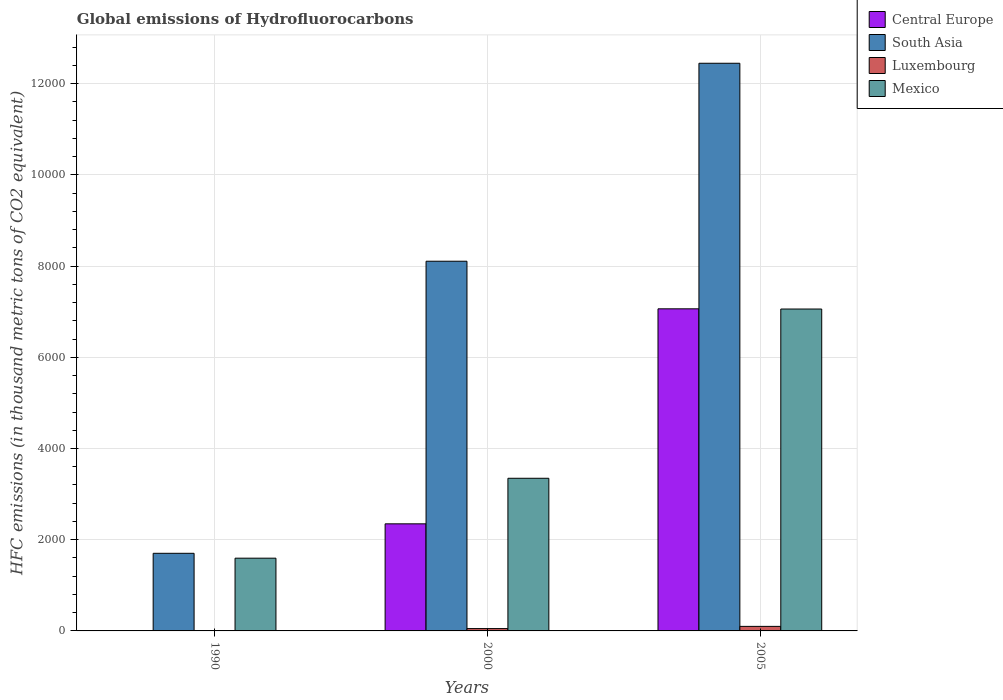Are the number of bars on each tick of the X-axis equal?
Offer a terse response. Yes. How many bars are there on the 1st tick from the right?
Your response must be concise. 4. What is the global emissions of Hydrofluorocarbons in Mexico in 1990?
Make the answer very short. 1595.3. Across all years, what is the maximum global emissions of Hydrofluorocarbons in Central Europe?
Give a very brief answer. 7063.3. In which year was the global emissions of Hydrofluorocarbons in Mexico maximum?
Your answer should be very brief. 2005. What is the total global emissions of Hydrofluorocarbons in South Asia in the graph?
Offer a terse response. 2.23e+04. What is the difference between the global emissions of Hydrofluorocarbons in South Asia in 2000 and that in 2005?
Ensure brevity in your answer.  -4341.26. What is the difference between the global emissions of Hydrofluorocarbons in Mexico in 2000 and the global emissions of Hydrofluorocarbons in South Asia in 1990?
Give a very brief answer. 1645.2. What is the average global emissions of Hydrofluorocarbons in South Asia per year?
Make the answer very short. 7419.25. In the year 1990, what is the difference between the global emissions of Hydrofluorocarbons in Luxembourg and global emissions of Hydrofluorocarbons in South Asia?
Give a very brief answer. -1702. What is the ratio of the global emissions of Hydrofluorocarbons in Central Europe in 1990 to that in 2005?
Your response must be concise. 7.078844166324523e-5. What is the difference between the highest and the second highest global emissions of Hydrofluorocarbons in Mexico?
Provide a succinct answer. 3711.6. What is the difference between the highest and the lowest global emissions of Hydrofluorocarbons in Luxembourg?
Your answer should be compact. 99.4. In how many years, is the global emissions of Hydrofluorocarbons in Luxembourg greater than the average global emissions of Hydrofluorocarbons in Luxembourg taken over all years?
Your response must be concise. 2. Is the sum of the global emissions of Hydrofluorocarbons in Luxembourg in 1990 and 2005 greater than the maximum global emissions of Hydrofluorocarbons in Mexico across all years?
Your answer should be very brief. No. Is it the case that in every year, the sum of the global emissions of Hydrofluorocarbons in Mexico and global emissions of Hydrofluorocarbons in Luxembourg is greater than the sum of global emissions of Hydrofluorocarbons in South Asia and global emissions of Hydrofluorocarbons in Central Europe?
Provide a short and direct response. No. What does the 4th bar from the left in 2005 represents?
Offer a terse response. Mexico. What does the 2nd bar from the right in 1990 represents?
Provide a short and direct response. Luxembourg. How many bars are there?
Ensure brevity in your answer.  12. How many years are there in the graph?
Offer a terse response. 3. What is the difference between two consecutive major ticks on the Y-axis?
Give a very brief answer. 2000. Are the values on the major ticks of Y-axis written in scientific E-notation?
Ensure brevity in your answer.  No. Does the graph contain any zero values?
Give a very brief answer. No. Does the graph contain grids?
Keep it short and to the point. Yes. How are the legend labels stacked?
Offer a very short reply. Vertical. What is the title of the graph?
Your answer should be compact. Global emissions of Hydrofluorocarbons. What is the label or title of the Y-axis?
Your answer should be very brief. HFC emissions (in thousand metric tons of CO2 equivalent). What is the HFC emissions (in thousand metric tons of CO2 equivalent) in Central Europe in 1990?
Your answer should be compact. 0.5. What is the HFC emissions (in thousand metric tons of CO2 equivalent) in South Asia in 1990?
Offer a very short reply. 1702.1. What is the HFC emissions (in thousand metric tons of CO2 equivalent) of Luxembourg in 1990?
Offer a very short reply. 0.1. What is the HFC emissions (in thousand metric tons of CO2 equivalent) in Mexico in 1990?
Offer a very short reply. 1595.3. What is the HFC emissions (in thousand metric tons of CO2 equivalent) of Central Europe in 2000?
Offer a terse response. 2348.2. What is the HFC emissions (in thousand metric tons of CO2 equivalent) of South Asia in 2000?
Give a very brief answer. 8107.2. What is the HFC emissions (in thousand metric tons of CO2 equivalent) in Luxembourg in 2000?
Your response must be concise. 51.1. What is the HFC emissions (in thousand metric tons of CO2 equivalent) of Mexico in 2000?
Provide a short and direct response. 3347.3. What is the HFC emissions (in thousand metric tons of CO2 equivalent) of Central Europe in 2005?
Offer a very short reply. 7063.3. What is the HFC emissions (in thousand metric tons of CO2 equivalent) of South Asia in 2005?
Your answer should be very brief. 1.24e+04. What is the HFC emissions (in thousand metric tons of CO2 equivalent) of Luxembourg in 2005?
Your answer should be very brief. 99.5. What is the HFC emissions (in thousand metric tons of CO2 equivalent) of Mexico in 2005?
Provide a succinct answer. 7058.9. Across all years, what is the maximum HFC emissions (in thousand metric tons of CO2 equivalent) in Central Europe?
Offer a very short reply. 7063.3. Across all years, what is the maximum HFC emissions (in thousand metric tons of CO2 equivalent) of South Asia?
Offer a terse response. 1.24e+04. Across all years, what is the maximum HFC emissions (in thousand metric tons of CO2 equivalent) of Luxembourg?
Give a very brief answer. 99.5. Across all years, what is the maximum HFC emissions (in thousand metric tons of CO2 equivalent) of Mexico?
Your answer should be very brief. 7058.9. Across all years, what is the minimum HFC emissions (in thousand metric tons of CO2 equivalent) in South Asia?
Provide a short and direct response. 1702.1. Across all years, what is the minimum HFC emissions (in thousand metric tons of CO2 equivalent) of Luxembourg?
Your response must be concise. 0.1. Across all years, what is the minimum HFC emissions (in thousand metric tons of CO2 equivalent) in Mexico?
Your response must be concise. 1595.3. What is the total HFC emissions (in thousand metric tons of CO2 equivalent) of Central Europe in the graph?
Offer a terse response. 9412. What is the total HFC emissions (in thousand metric tons of CO2 equivalent) in South Asia in the graph?
Provide a short and direct response. 2.23e+04. What is the total HFC emissions (in thousand metric tons of CO2 equivalent) of Luxembourg in the graph?
Your answer should be compact. 150.7. What is the total HFC emissions (in thousand metric tons of CO2 equivalent) in Mexico in the graph?
Your answer should be compact. 1.20e+04. What is the difference between the HFC emissions (in thousand metric tons of CO2 equivalent) in Central Europe in 1990 and that in 2000?
Offer a terse response. -2347.7. What is the difference between the HFC emissions (in thousand metric tons of CO2 equivalent) in South Asia in 1990 and that in 2000?
Offer a very short reply. -6405.1. What is the difference between the HFC emissions (in thousand metric tons of CO2 equivalent) in Luxembourg in 1990 and that in 2000?
Provide a succinct answer. -51. What is the difference between the HFC emissions (in thousand metric tons of CO2 equivalent) of Mexico in 1990 and that in 2000?
Ensure brevity in your answer.  -1752. What is the difference between the HFC emissions (in thousand metric tons of CO2 equivalent) in Central Europe in 1990 and that in 2005?
Provide a short and direct response. -7062.8. What is the difference between the HFC emissions (in thousand metric tons of CO2 equivalent) in South Asia in 1990 and that in 2005?
Your answer should be compact. -1.07e+04. What is the difference between the HFC emissions (in thousand metric tons of CO2 equivalent) of Luxembourg in 1990 and that in 2005?
Ensure brevity in your answer.  -99.4. What is the difference between the HFC emissions (in thousand metric tons of CO2 equivalent) in Mexico in 1990 and that in 2005?
Offer a terse response. -5463.6. What is the difference between the HFC emissions (in thousand metric tons of CO2 equivalent) in Central Europe in 2000 and that in 2005?
Keep it short and to the point. -4715.1. What is the difference between the HFC emissions (in thousand metric tons of CO2 equivalent) in South Asia in 2000 and that in 2005?
Keep it short and to the point. -4341.26. What is the difference between the HFC emissions (in thousand metric tons of CO2 equivalent) of Luxembourg in 2000 and that in 2005?
Offer a terse response. -48.4. What is the difference between the HFC emissions (in thousand metric tons of CO2 equivalent) in Mexico in 2000 and that in 2005?
Your answer should be very brief. -3711.6. What is the difference between the HFC emissions (in thousand metric tons of CO2 equivalent) in Central Europe in 1990 and the HFC emissions (in thousand metric tons of CO2 equivalent) in South Asia in 2000?
Ensure brevity in your answer.  -8106.7. What is the difference between the HFC emissions (in thousand metric tons of CO2 equivalent) in Central Europe in 1990 and the HFC emissions (in thousand metric tons of CO2 equivalent) in Luxembourg in 2000?
Give a very brief answer. -50.6. What is the difference between the HFC emissions (in thousand metric tons of CO2 equivalent) in Central Europe in 1990 and the HFC emissions (in thousand metric tons of CO2 equivalent) in Mexico in 2000?
Offer a very short reply. -3346.8. What is the difference between the HFC emissions (in thousand metric tons of CO2 equivalent) of South Asia in 1990 and the HFC emissions (in thousand metric tons of CO2 equivalent) of Luxembourg in 2000?
Your answer should be compact. 1651. What is the difference between the HFC emissions (in thousand metric tons of CO2 equivalent) of South Asia in 1990 and the HFC emissions (in thousand metric tons of CO2 equivalent) of Mexico in 2000?
Your answer should be very brief. -1645.2. What is the difference between the HFC emissions (in thousand metric tons of CO2 equivalent) of Luxembourg in 1990 and the HFC emissions (in thousand metric tons of CO2 equivalent) of Mexico in 2000?
Provide a short and direct response. -3347.2. What is the difference between the HFC emissions (in thousand metric tons of CO2 equivalent) in Central Europe in 1990 and the HFC emissions (in thousand metric tons of CO2 equivalent) in South Asia in 2005?
Offer a very short reply. -1.24e+04. What is the difference between the HFC emissions (in thousand metric tons of CO2 equivalent) of Central Europe in 1990 and the HFC emissions (in thousand metric tons of CO2 equivalent) of Luxembourg in 2005?
Provide a succinct answer. -99. What is the difference between the HFC emissions (in thousand metric tons of CO2 equivalent) in Central Europe in 1990 and the HFC emissions (in thousand metric tons of CO2 equivalent) in Mexico in 2005?
Keep it short and to the point. -7058.4. What is the difference between the HFC emissions (in thousand metric tons of CO2 equivalent) of South Asia in 1990 and the HFC emissions (in thousand metric tons of CO2 equivalent) of Luxembourg in 2005?
Provide a succinct answer. 1602.6. What is the difference between the HFC emissions (in thousand metric tons of CO2 equivalent) of South Asia in 1990 and the HFC emissions (in thousand metric tons of CO2 equivalent) of Mexico in 2005?
Keep it short and to the point. -5356.8. What is the difference between the HFC emissions (in thousand metric tons of CO2 equivalent) in Luxembourg in 1990 and the HFC emissions (in thousand metric tons of CO2 equivalent) in Mexico in 2005?
Make the answer very short. -7058.8. What is the difference between the HFC emissions (in thousand metric tons of CO2 equivalent) in Central Europe in 2000 and the HFC emissions (in thousand metric tons of CO2 equivalent) in South Asia in 2005?
Offer a terse response. -1.01e+04. What is the difference between the HFC emissions (in thousand metric tons of CO2 equivalent) of Central Europe in 2000 and the HFC emissions (in thousand metric tons of CO2 equivalent) of Luxembourg in 2005?
Ensure brevity in your answer.  2248.7. What is the difference between the HFC emissions (in thousand metric tons of CO2 equivalent) in Central Europe in 2000 and the HFC emissions (in thousand metric tons of CO2 equivalent) in Mexico in 2005?
Provide a succinct answer. -4710.7. What is the difference between the HFC emissions (in thousand metric tons of CO2 equivalent) in South Asia in 2000 and the HFC emissions (in thousand metric tons of CO2 equivalent) in Luxembourg in 2005?
Provide a short and direct response. 8007.7. What is the difference between the HFC emissions (in thousand metric tons of CO2 equivalent) of South Asia in 2000 and the HFC emissions (in thousand metric tons of CO2 equivalent) of Mexico in 2005?
Make the answer very short. 1048.3. What is the difference between the HFC emissions (in thousand metric tons of CO2 equivalent) in Luxembourg in 2000 and the HFC emissions (in thousand metric tons of CO2 equivalent) in Mexico in 2005?
Offer a very short reply. -7007.8. What is the average HFC emissions (in thousand metric tons of CO2 equivalent) in Central Europe per year?
Provide a short and direct response. 3137.33. What is the average HFC emissions (in thousand metric tons of CO2 equivalent) in South Asia per year?
Your answer should be compact. 7419.25. What is the average HFC emissions (in thousand metric tons of CO2 equivalent) in Luxembourg per year?
Your answer should be very brief. 50.23. What is the average HFC emissions (in thousand metric tons of CO2 equivalent) in Mexico per year?
Keep it short and to the point. 4000.5. In the year 1990, what is the difference between the HFC emissions (in thousand metric tons of CO2 equivalent) of Central Europe and HFC emissions (in thousand metric tons of CO2 equivalent) of South Asia?
Give a very brief answer. -1701.6. In the year 1990, what is the difference between the HFC emissions (in thousand metric tons of CO2 equivalent) in Central Europe and HFC emissions (in thousand metric tons of CO2 equivalent) in Mexico?
Provide a short and direct response. -1594.8. In the year 1990, what is the difference between the HFC emissions (in thousand metric tons of CO2 equivalent) in South Asia and HFC emissions (in thousand metric tons of CO2 equivalent) in Luxembourg?
Provide a succinct answer. 1702. In the year 1990, what is the difference between the HFC emissions (in thousand metric tons of CO2 equivalent) of South Asia and HFC emissions (in thousand metric tons of CO2 equivalent) of Mexico?
Make the answer very short. 106.8. In the year 1990, what is the difference between the HFC emissions (in thousand metric tons of CO2 equivalent) of Luxembourg and HFC emissions (in thousand metric tons of CO2 equivalent) of Mexico?
Ensure brevity in your answer.  -1595.2. In the year 2000, what is the difference between the HFC emissions (in thousand metric tons of CO2 equivalent) in Central Europe and HFC emissions (in thousand metric tons of CO2 equivalent) in South Asia?
Provide a short and direct response. -5759. In the year 2000, what is the difference between the HFC emissions (in thousand metric tons of CO2 equivalent) of Central Europe and HFC emissions (in thousand metric tons of CO2 equivalent) of Luxembourg?
Make the answer very short. 2297.1. In the year 2000, what is the difference between the HFC emissions (in thousand metric tons of CO2 equivalent) in Central Europe and HFC emissions (in thousand metric tons of CO2 equivalent) in Mexico?
Give a very brief answer. -999.1. In the year 2000, what is the difference between the HFC emissions (in thousand metric tons of CO2 equivalent) of South Asia and HFC emissions (in thousand metric tons of CO2 equivalent) of Luxembourg?
Keep it short and to the point. 8056.1. In the year 2000, what is the difference between the HFC emissions (in thousand metric tons of CO2 equivalent) of South Asia and HFC emissions (in thousand metric tons of CO2 equivalent) of Mexico?
Provide a succinct answer. 4759.9. In the year 2000, what is the difference between the HFC emissions (in thousand metric tons of CO2 equivalent) of Luxembourg and HFC emissions (in thousand metric tons of CO2 equivalent) of Mexico?
Keep it short and to the point. -3296.2. In the year 2005, what is the difference between the HFC emissions (in thousand metric tons of CO2 equivalent) of Central Europe and HFC emissions (in thousand metric tons of CO2 equivalent) of South Asia?
Make the answer very short. -5385.16. In the year 2005, what is the difference between the HFC emissions (in thousand metric tons of CO2 equivalent) in Central Europe and HFC emissions (in thousand metric tons of CO2 equivalent) in Luxembourg?
Provide a succinct answer. 6963.8. In the year 2005, what is the difference between the HFC emissions (in thousand metric tons of CO2 equivalent) of South Asia and HFC emissions (in thousand metric tons of CO2 equivalent) of Luxembourg?
Your answer should be very brief. 1.23e+04. In the year 2005, what is the difference between the HFC emissions (in thousand metric tons of CO2 equivalent) in South Asia and HFC emissions (in thousand metric tons of CO2 equivalent) in Mexico?
Give a very brief answer. 5389.56. In the year 2005, what is the difference between the HFC emissions (in thousand metric tons of CO2 equivalent) in Luxembourg and HFC emissions (in thousand metric tons of CO2 equivalent) in Mexico?
Provide a short and direct response. -6959.4. What is the ratio of the HFC emissions (in thousand metric tons of CO2 equivalent) in South Asia in 1990 to that in 2000?
Keep it short and to the point. 0.21. What is the ratio of the HFC emissions (in thousand metric tons of CO2 equivalent) in Luxembourg in 1990 to that in 2000?
Provide a succinct answer. 0. What is the ratio of the HFC emissions (in thousand metric tons of CO2 equivalent) of Mexico in 1990 to that in 2000?
Your answer should be compact. 0.48. What is the ratio of the HFC emissions (in thousand metric tons of CO2 equivalent) in Central Europe in 1990 to that in 2005?
Keep it short and to the point. 0. What is the ratio of the HFC emissions (in thousand metric tons of CO2 equivalent) in South Asia in 1990 to that in 2005?
Your answer should be very brief. 0.14. What is the ratio of the HFC emissions (in thousand metric tons of CO2 equivalent) in Luxembourg in 1990 to that in 2005?
Ensure brevity in your answer.  0. What is the ratio of the HFC emissions (in thousand metric tons of CO2 equivalent) of Mexico in 1990 to that in 2005?
Keep it short and to the point. 0.23. What is the ratio of the HFC emissions (in thousand metric tons of CO2 equivalent) in Central Europe in 2000 to that in 2005?
Offer a terse response. 0.33. What is the ratio of the HFC emissions (in thousand metric tons of CO2 equivalent) of South Asia in 2000 to that in 2005?
Your answer should be very brief. 0.65. What is the ratio of the HFC emissions (in thousand metric tons of CO2 equivalent) of Luxembourg in 2000 to that in 2005?
Your response must be concise. 0.51. What is the ratio of the HFC emissions (in thousand metric tons of CO2 equivalent) in Mexico in 2000 to that in 2005?
Your answer should be very brief. 0.47. What is the difference between the highest and the second highest HFC emissions (in thousand metric tons of CO2 equivalent) of Central Europe?
Ensure brevity in your answer.  4715.1. What is the difference between the highest and the second highest HFC emissions (in thousand metric tons of CO2 equivalent) of South Asia?
Provide a short and direct response. 4341.26. What is the difference between the highest and the second highest HFC emissions (in thousand metric tons of CO2 equivalent) in Luxembourg?
Your answer should be very brief. 48.4. What is the difference between the highest and the second highest HFC emissions (in thousand metric tons of CO2 equivalent) in Mexico?
Give a very brief answer. 3711.6. What is the difference between the highest and the lowest HFC emissions (in thousand metric tons of CO2 equivalent) of Central Europe?
Your answer should be very brief. 7062.8. What is the difference between the highest and the lowest HFC emissions (in thousand metric tons of CO2 equivalent) of South Asia?
Provide a short and direct response. 1.07e+04. What is the difference between the highest and the lowest HFC emissions (in thousand metric tons of CO2 equivalent) of Luxembourg?
Keep it short and to the point. 99.4. What is the difference between the highest and the lowest HFC emissions (in thousand metric tons of CO2 equivalent) in Mexico?
Your response must be concise. 5463.6. 